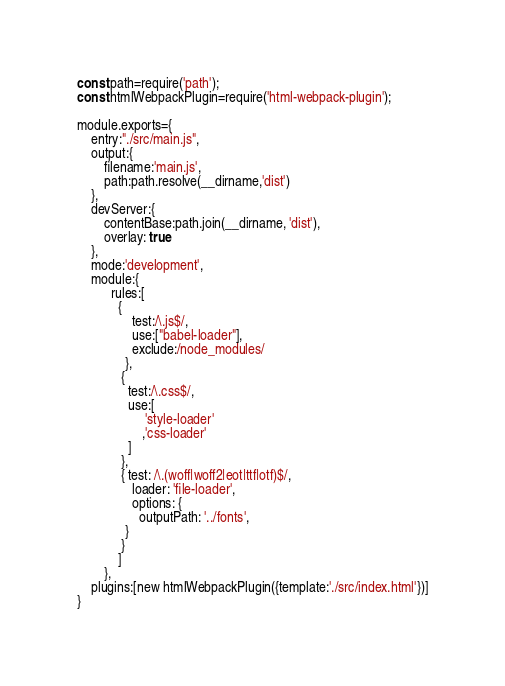Convert code to text. <code><loc_0><loc_0><loc_500><loc_500><_JavaScript_>const path=require('path');
const htmlWebpackPlugin=require('html-webpack-plugin');

module.exports={
    entry:"./src/main.js",
    output:{
        filename:'main.js',
        path:path.resolve(__dirname,'dist')
    },
    devServer:{
        contentBase:path.join(__dirname, 'dist'),
        overlay: true
    },
    mode:'development',
    module:{
          rules:[
            {
                test:/\.js$/,
                use:["babel-loader"],
                exclude:/node_modules/
              },
             {
               test:/\.css$/,
               use:[
                    'style-loader'
                   ,'css-loader'
               ]
             },
             { test: /\.(woff|woff2|eot|ttf|otf)$/,
                loader: 'file-loader',
                options: {
                  outputPath: '../fonts',
              }
             }
            ]
        },
    plugins:[new htmlWebpackPlugin({template:'./src/index.html'})]
}</code> 